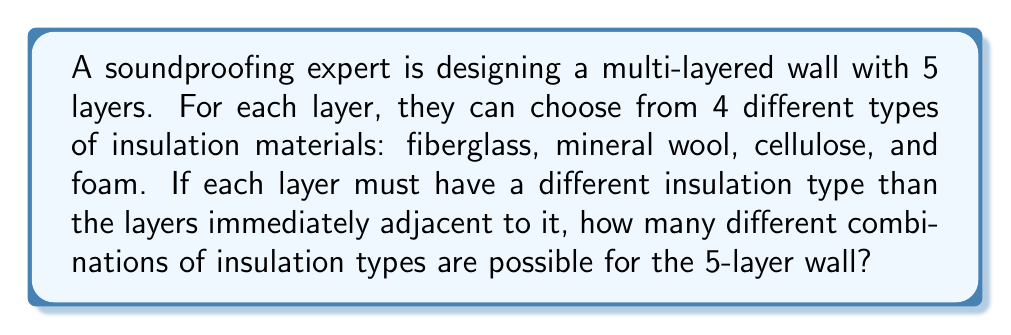Solve this math problem. To solve this problem, we'll use the multiplication principle and consider the choices for each layer:

1) For the first layer, we have 4 choices.

2) For the second layer, we can't use the same material as the first layer, so we have 3 choices.

3) For the third layer, we can't use the same material as the second layer, but we can use the material from the first layer. So we have 3 choices.

4) For the fourth layer, we can't use the same material as the third layer, so we have 3 choices.

5) For the fifth layer, we can't use the same material as the fourth layer, but we can use the material from the third layer. So we have 3 choices.

Therefore, the total number of combinations is:

$$4 \times 3 \times 3 \times 3 \times 3 = 4 \times 3^4 = 324$$

We can verify this result using the multiplication principle:

$$\text{Total combinations} = \text{Choices for Layer 1} \times \text{Choices for Layer 2} \times \text{Choices for Layer 3} \times \text{Choices for Layer 4} \times \text{Choices for Layer 5}$$

$$= 4 \times 3 \times 3 \times 3 \times 3 = 324$$
Answer: 324 combinations 